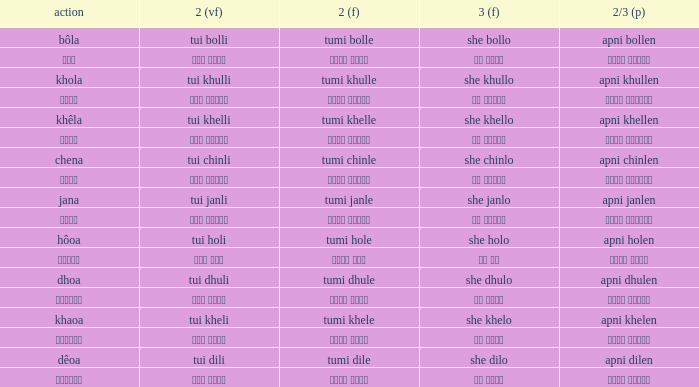What is the 2(vf) for তুমি বললে? তুই বললি. 